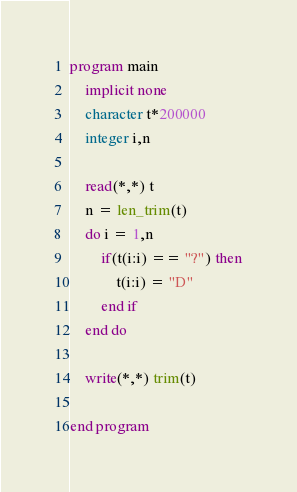Convert code to text. <code><loc_0><loc_0><loc_500><loc_500><_FORTRAN_>program main
    implicit none
    character t*200000
    integer i,n

    read(*,*) t
    n = len_trim(t)
    do i = 1,n
        if(t(i:i) == "?") then
            t(i:i) = "D"
        end if
    end do

    write(*,*) trim(t)

end program

</code> 